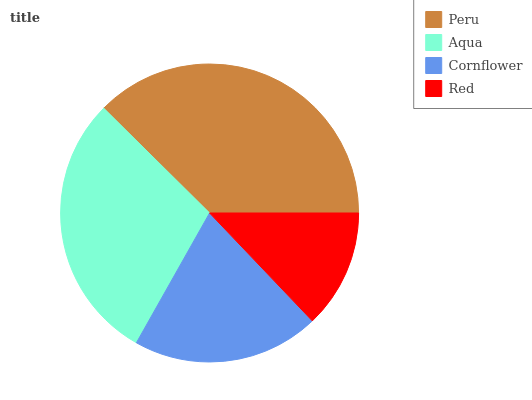Is Red the minimum?
Answer yes or no. Yes. Is Peru the maximum?
Answer yes or no. Yes. Is Aqua the minimum?
Answer yes or no. No. Is Aqua the maximum?
Answer yes or no. No. Is Peru greater than Aqua?
Answer yes or no. Yes. Is Aqua less than Peru?
Answer yes or no. Yes. Is Aqua greater than Peru?
Answer yes or no. No. Is Peru less than Aqua?
Answer yes or no. No. Is Aqua the high median?
Answer yes or no. Yes. Is Cornflower the low median?
Answer yes or no. Yes. Is Cornflower the high median?
Answer yes or no. No. Is Aqua the low median?
Answer yes or no. No. 